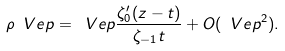<formula> <loc_0><loc_0><loc_500><loc_500>\rho ^ { \ } V e p = \ V e p \frac { \zeta ^ { \prime } _ { 0 } ( z - t ) } { \zeta _ { - 1 } t } + O ( \ V e p ^ { 2 } ) .</formula> 